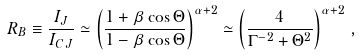Convert formula to latex. <formula><loc_0><loc_0><loc_500><loc_500>R _ { B } \equiv \frac { I _ { J } } { I _ { C J } } \simeq \left ( \frac { 1 + \beta \cos \Theta } { 1 - \beta \cos \Theta } \right ) ^ { \alpha + 2 } \simeq \left ( \frac { 4 } { \Gamma ^ { - 2 } + \Theta ^ { 2 } } \right ) ^ { \alpha + 2 } \, ,</formula> 